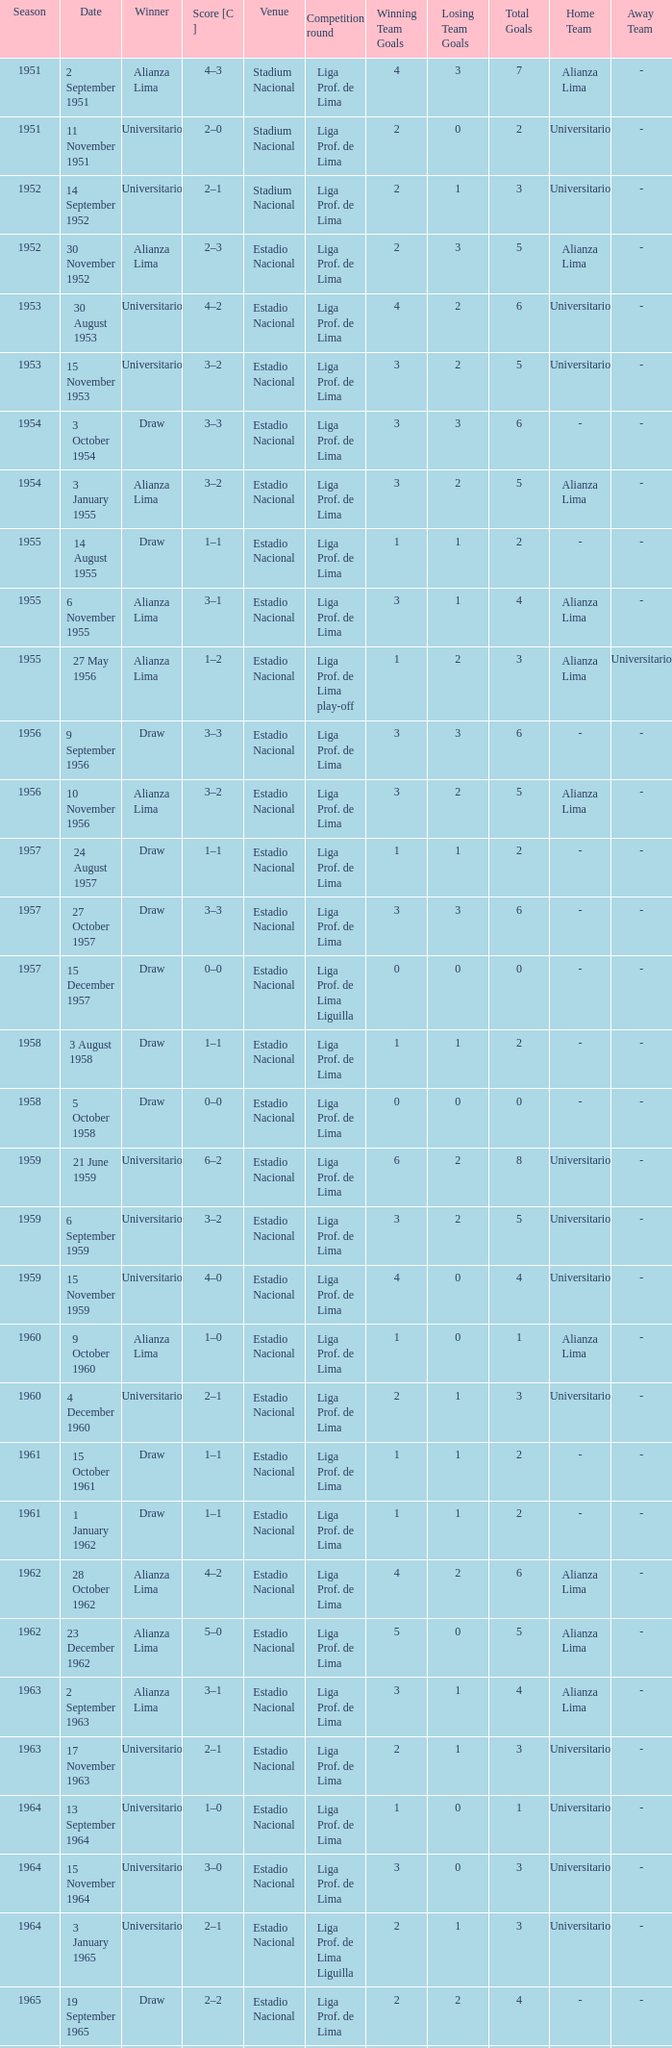Who was the winner on 15 December 1957? Draw. 